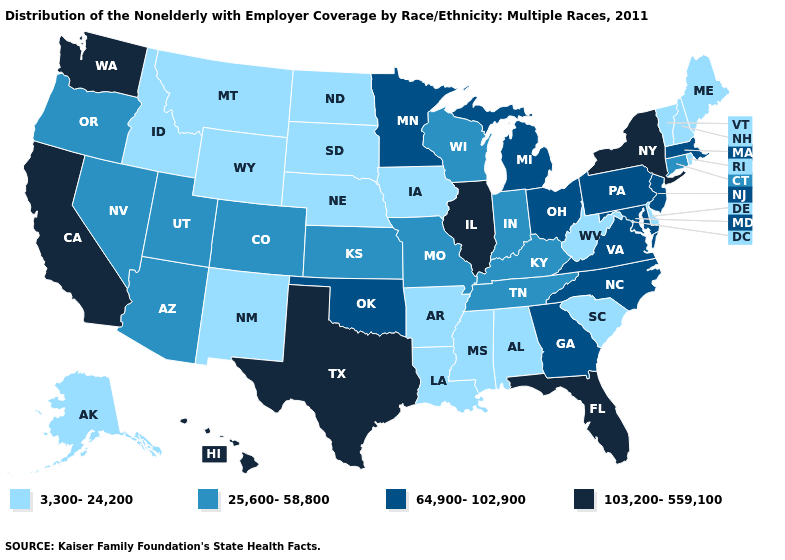Which states have the lowest value in the Northeast?
Short answer required. Maine, New Hampshire, Rhode Island, Vermont. What is the value of Arizona?
Concise answer only. 25,600-58,800. Does Arizona have a lower value than Illinois?
Be succinct. Yes. What is the value of Michigan?
Be succinct. 64,900-102,900. Which states have the highest value in the USA?
Give a very brief answer. California, Florida, Hawaii, Illinois, New York, Texas, Washington. What is the value of Louisiana?
Quick response, please. 3,300-24,200. Among the states that border Connecticut , which have the lowest value?
Quick response, please. Rhode Island. Name the states that have a value in the range 64,900-102,900?
Be succinct. Georgia, Maryland, Massachusetts, Michigan, Minnesota, New Jersey, North Carolina, Ohio, Oklahoma, Pennsylvania, Virginia. Name the states that have a value in the range 103,200-559,100?
Write a very short answer. California, Florida, Hawaii, Illinois, New York, Texas, Washington. What is the value of West Virginia?
Keep it brief. 3,300-24,200. Does the map have missing data?
Be succinct. No. What is the value of Georgia?
Give a very brief answer. 64,900-102,900. Name the states that have a value in the range 3,300-24,200?
Be succinct. Alabama, Alaska, Arkansas, Delaware, Idaho, Iowa, Louisiana, Maine, Mississippi, Montana, Nebraska, New Hampshire, New Mexico, North Dakota, Rhode Island, South Carolina, South Dakota, Vermont, West Virginia, Wyoming. What is the highest value in the Northeast ?
Keep it brief. 103,200-559,100. Does Wyoming have the highest value in the West?
Keep it brief. No. 